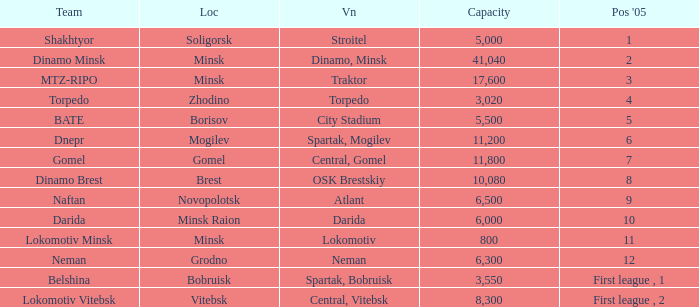I'm looking to parse the entire table for insights. Could you assist me with that? {'header': ['Team', 'Loc', 'Vn', 'Capacity', "Pos '05"], 'rows': [['Shakhtyor', 'Soligorsk', 'Stroitel', '5,000', '1'], ['Dinamo Minsk', 'Minsk', 'Dinamo, Minsk', '41,040', '2'], ['MTZ-RIPO', 'Minsk', 'Traktor', '17,600', '3'], ['Torpedo', 'Zhodino', 'Torpedo', '3,020', '4'], ['BATE', 'Borisov', 'City Stadium', '5,500', '5'], ['Dnepr', 'Mogilev', 'Spartak, Mogilev', '11,200', '6'], ['Gomel', 'Gomel', 'Central, Gomel', '11,800', '7'], ['Dinamo Brest', 'Brest', 'OSK Brestskiy', '10,080', '8'], ['Naftan', 'Novopolotsk', 'Atlant', '6,500', '9'], ['Darida', 'Minsk Raion', 'Darida', '6,000', '10'], ['Lokomotiv Minsk', 'Minsk', 'Lokomotiv', '800', '11'], ['Neman', 'Grodno', 'Neman', '6,300', '12'], ['Belshina', 'Bobruisk', 'Spartak, Bobruisk', '3,550', 'First league , 1'], ['Lokomotiv Vitebsk', 'Vitebsk', 'Central, Vitebsk', '8,300', 'First league , 2']]} Can you tell me the Venue that has the Position in 2005 of 8? OSK Brestskiy. 